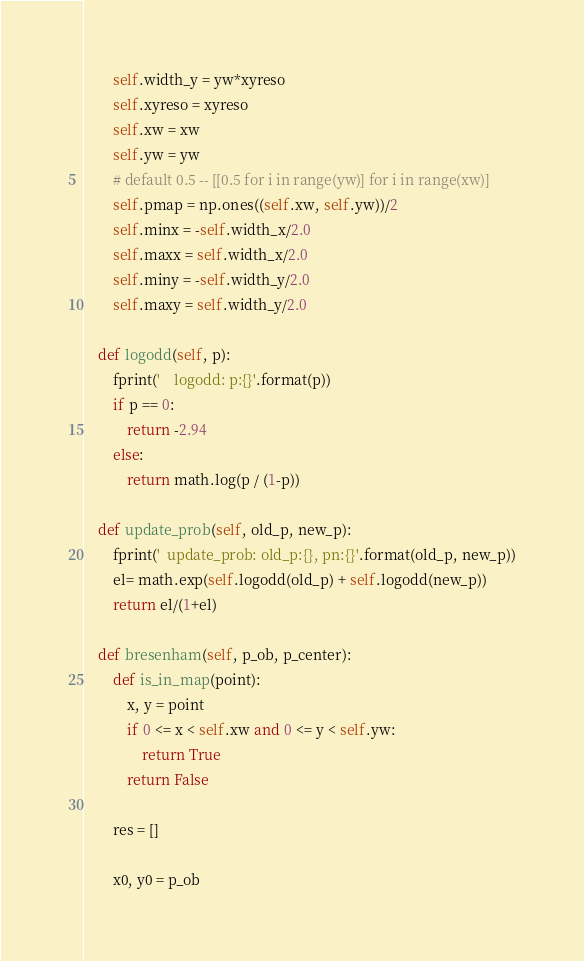Convert code to text. <code><loc_0><loc_0><loc_500><loc_500><_Python_>        self.width_y = yw*xyreso
        self.xyreso = xyreso
        self.xw = xw
        self.yw = yw
        # default 0.5 -- [[0.5 for i in range(yw)] for i in range(xw)]
        self.pmap = np.ones((self.xw, self.yw))/2
        self.minx = -self.width_x/2.0
        self.maxx = self.width_x/2.0
        self.miny = -self.width_y/2.0
        self.maxy = self.width_y/2.0

    def logodd(self, p):
        fprint('    logodd: p:{}'.format(p))
        if p == 0:
            return -2.94
        else: 
            return math.log(p / (1-p))

    def update_prob(self, old_p, new_p):
        fprint('  update_prob: old_p:{}, pn:{}'.format(old_p, new_p))
        el= math.exp(self.logodd(old_p) + self.logodd(new_p))
        return el/(1+el)

    def bresenham(self, p_ob, p_center):
        def is_in_map(point):
            x, y = point
            if 0 <= x < self.xw and 0 <= y < self.yw:
                return True
            return False

        res = []
        
        x0, y0 = p_ob</code> 